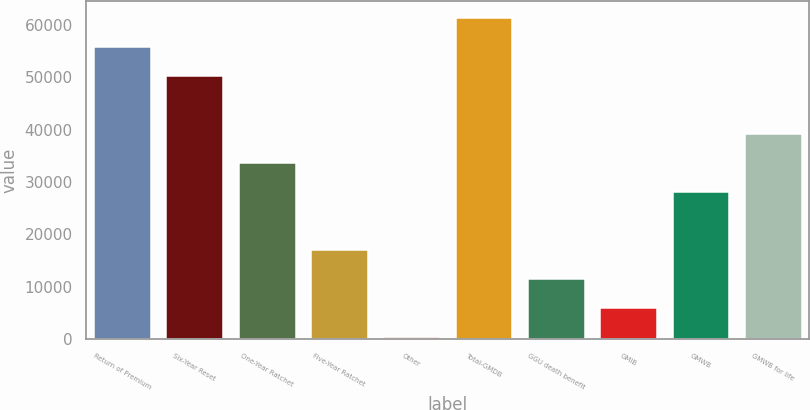Convert chart to OTSL. <chart><loc_0><loc_0><loc_500><loc_500><bar_chart><fcel>Return of Premium<fcel>Six-Year Reset<fcel>One-Year Ratchet<fcel>Five-Year Ratchet<fcel>Other<fcel>Total-GMDB<fcel>GGU death benefit<fcel>GMIB<fcel>GMWB<fcel>GMWB for life<nl><fcel>55847<fcel>50331.6<fcel>33785.4<fcel>17239.2<fcel>693<fcel>61362.4<fcel>11723.8<fcel>6208.4<fcel>28270<fcel>39300.8<nl></chart> 